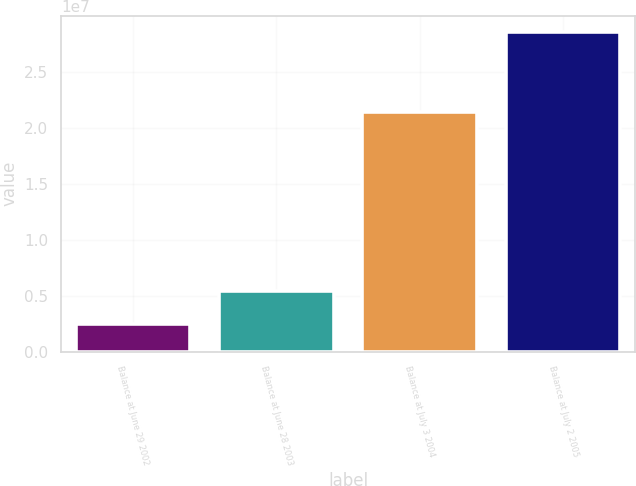Convert chart to OTSL. <chart><loc_0><loc_0><loc_500><loc_500><bar_chart><fcel>Balance at June 29 2002<fcel>Balance at June 28 2003<fcel>Balance at July 3 2004<fcel>Balance at July 2 2005<nl><fcel>2.42238e+06<fcel>5.39184e+06<fcel>2.14204e+07<fcel>2.85419e+07<nl></chart> 